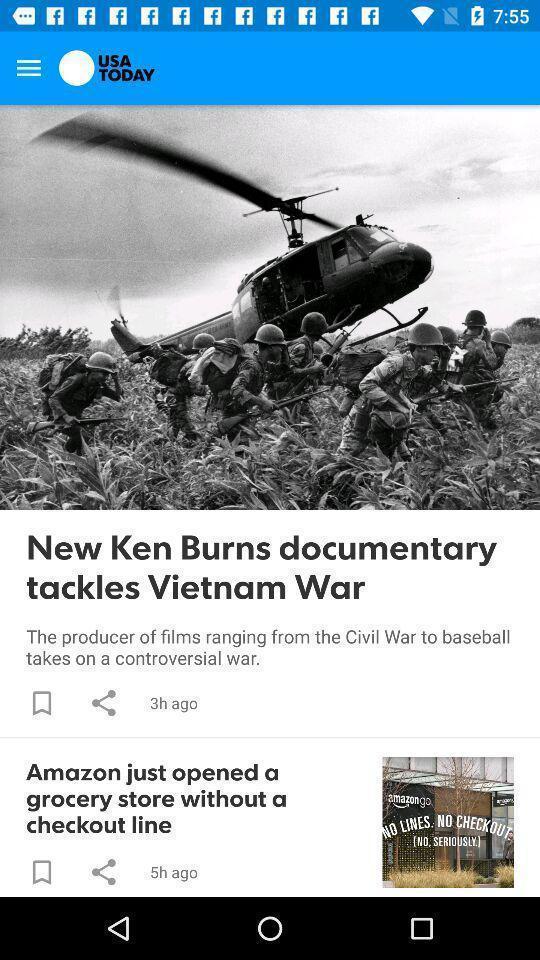Describe this image in words. Screen shows news articles. 